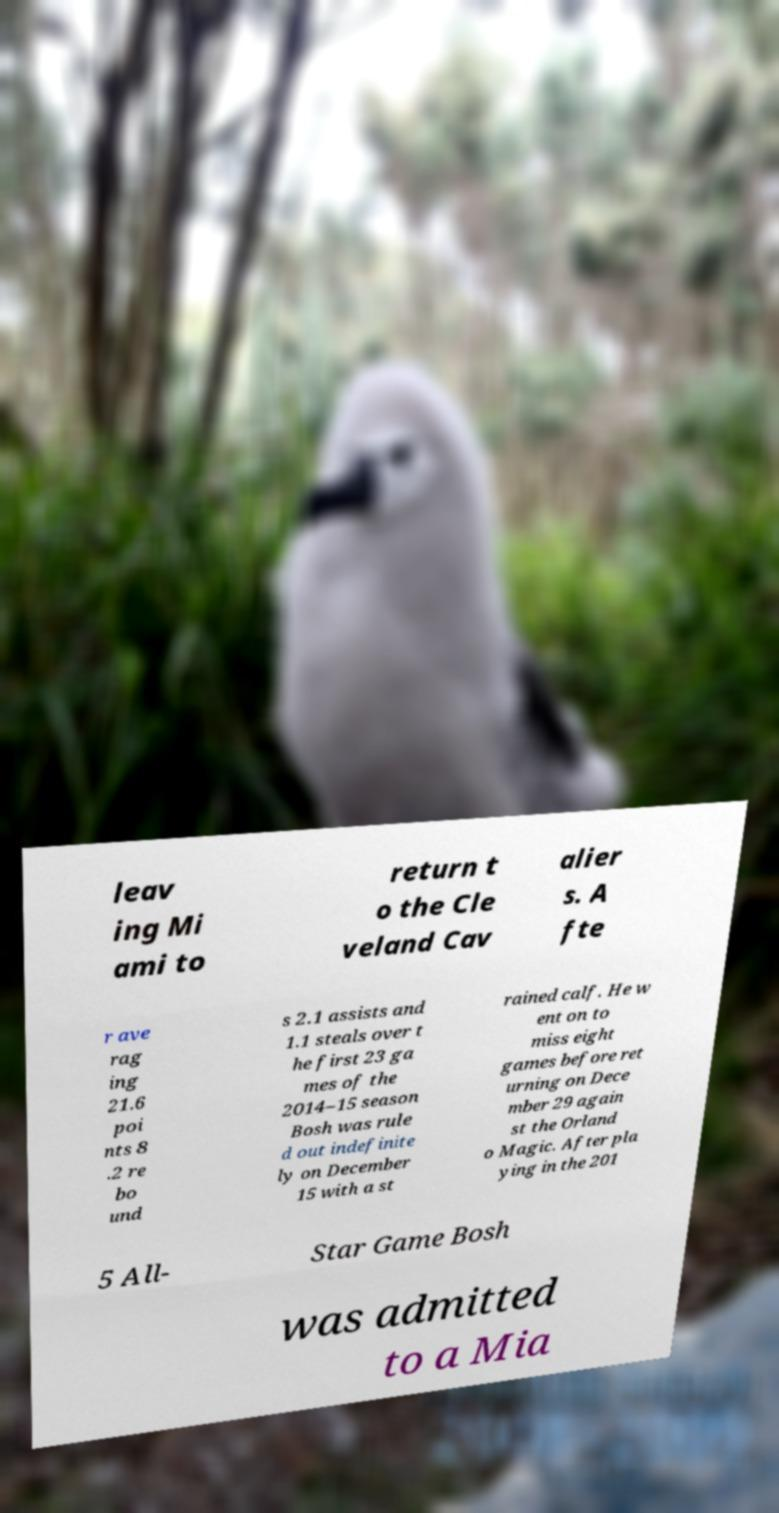Can you accurately transcribe the text from the provided image for me? leav ing Mi ami to return t o the Cle veland Cav alier s. A fte r ave rag ing 21.6 poi nts 8 .2 re bo und s 2.1 assists and 1.1 steals over t he first 23 ga mes of the 2014–15 season Bosh was rule d out indefinite ly on December 15 with a st rained calf. He w ent on to miss eight games before ret urning on Dece mber 29 again st the Orland o Magic. After pla ying in the 201 5 All- Star Game Bosh was admitted to a Mia 